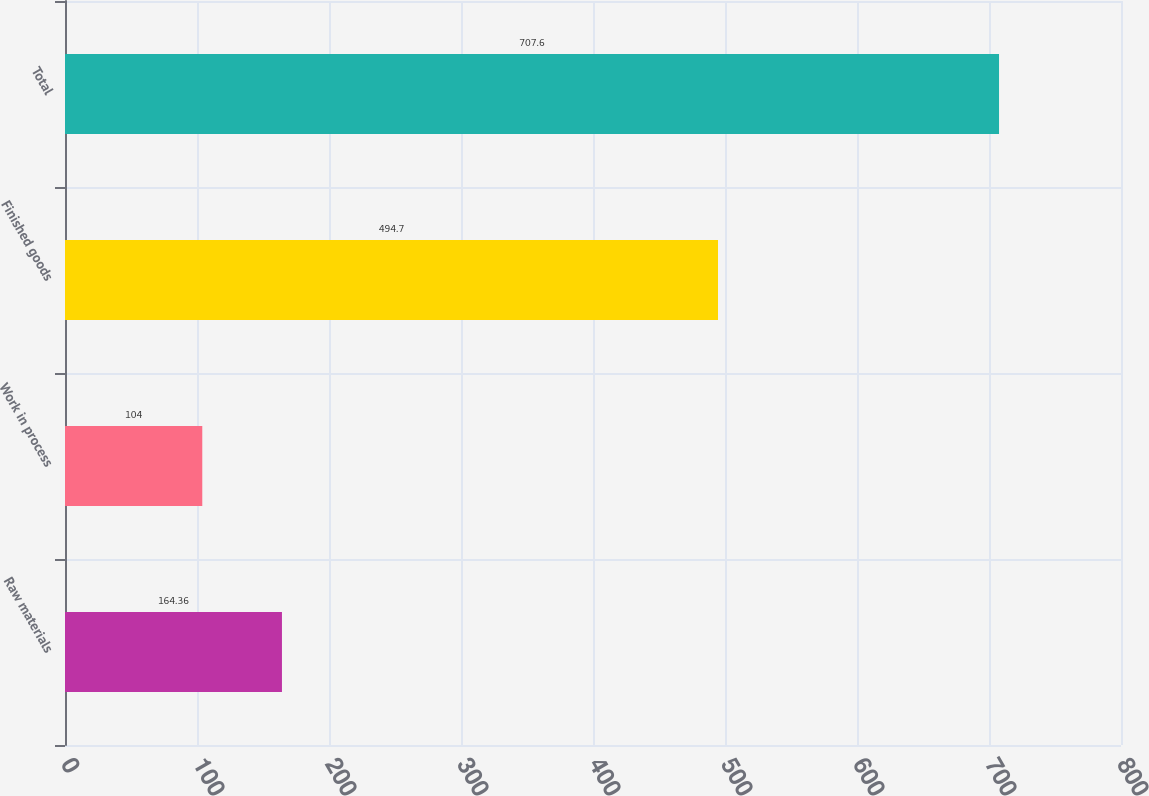Convert chart. <chart><loc_0><loc_0><loc_500><loc_500><bar_chart><fcel>Raw materials<fcel>Work in process<fcel>Finished goods<fcel>Total<nl><fcel>164.36<fcel>104<fcel>494.7<fcel>707.6<nl></chart> 